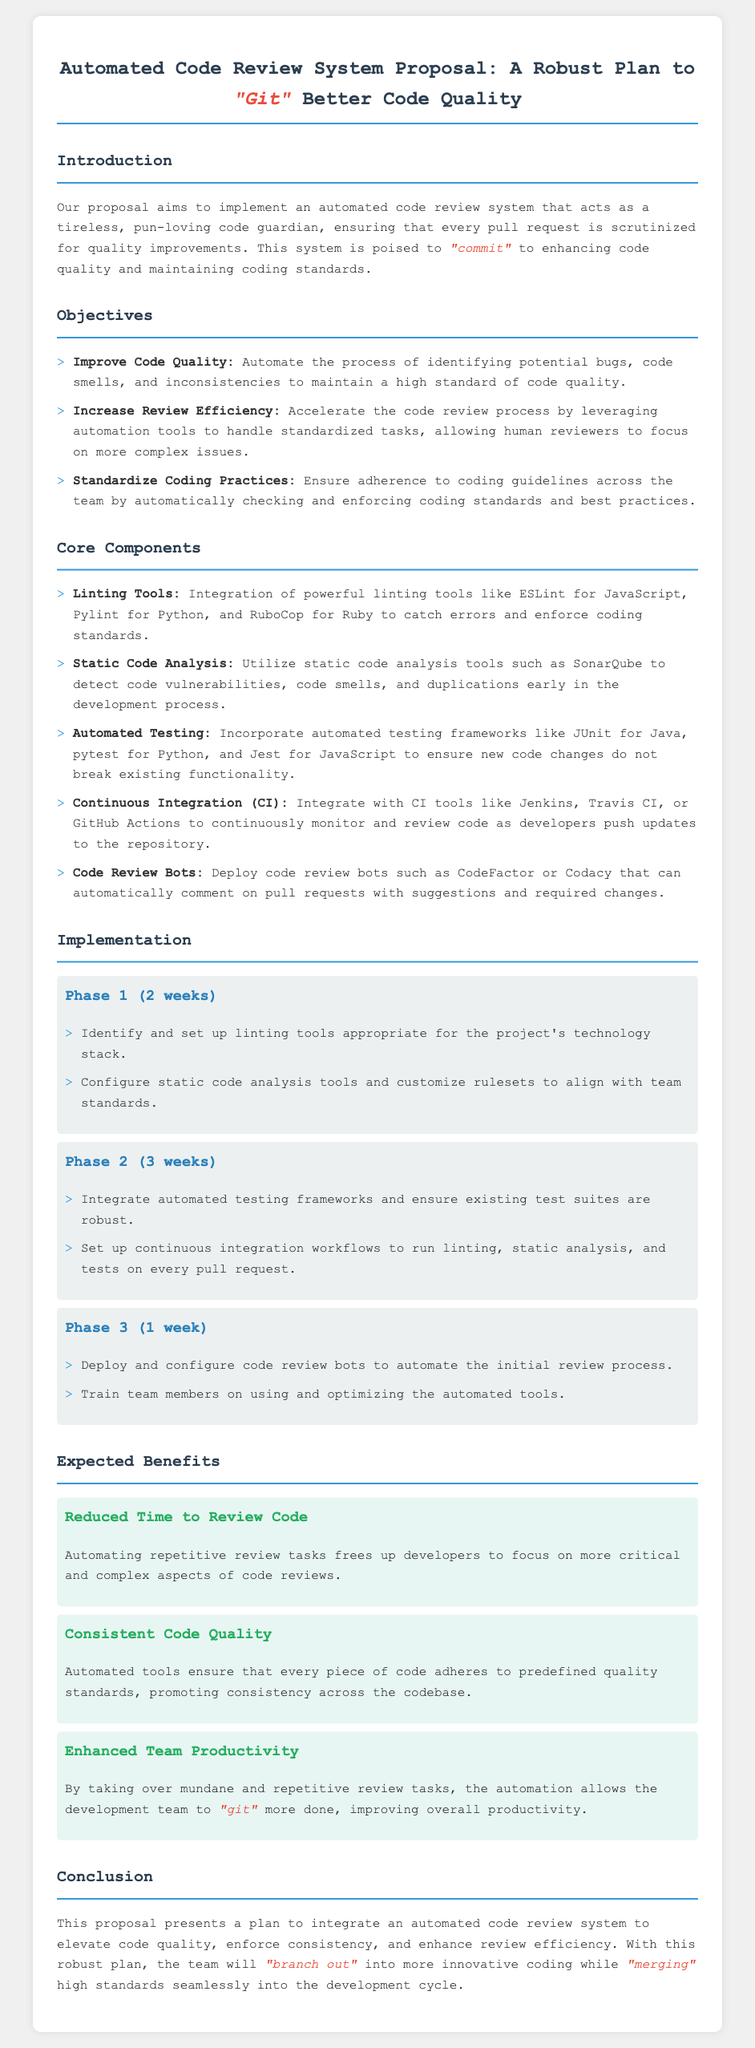What is the title of the proposal? The title of the proposal is stated at the top of the document.
Answer: Automated Code Review System Proposal: A Robust Plan to "Git" Better Code Quality How many phases are there in the implementation? The implementation section describes three phases.
Answer: 3 What is the expected benefit related to team productivity? The section on expected benefits mentions enhancing team productivity specifically.
Answer: Enhanced Team Productivity Which linting tool is mentioned for JavaScript? The core components section lists ESLint as the linting tool for JavaScript.
Answer: ESLint What is the duration of Phase 1? Phase 1 is specified to last for 2 weeks.
Answer: 2 weeks Name one automated testing framework mentioned in the proposal. Various automated testing frameworks are listed in the core components; any would suffice.
Answer: JUnit What coding standard enforcement tool is mentioned for Python? The document specifies Pylint as the relevant tool for Python.
Answer: Pylint What is one key objective of the proposed system? The objectives section outlines several goals, such as improving code quality.
Answer: Improve Code Quality What do team members get trained on in Phase 3? The final phase includes training team members on the use of automated tools.
Answer: Using and optimizing the automated tools 